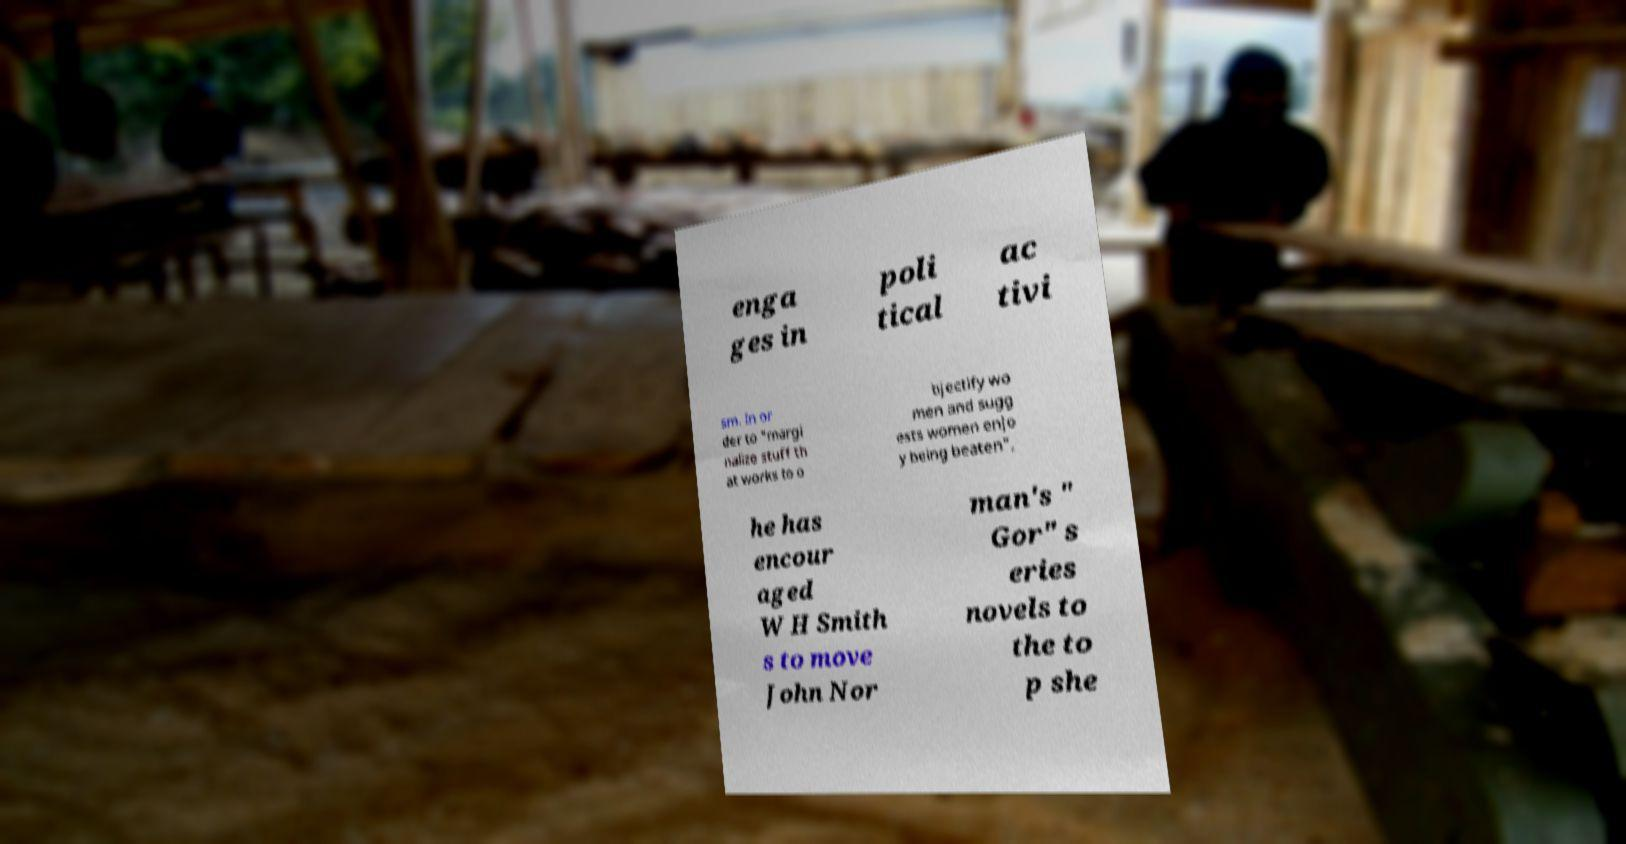Can you accurately transcribe the text from the provided image for me? enga ges in poli tical ac tivi sm. In or der to "margi nalize stuff th at works to o bjectify wo men and sugg ests women enjo y being beaten", he has encour aged W H Smith s to move John Nor man's " Gor" s eries novels to the to p she 